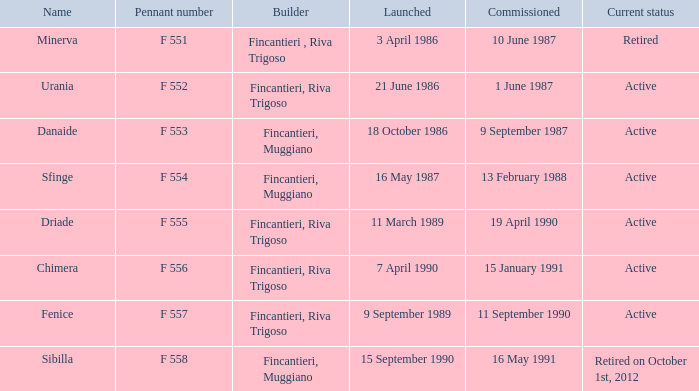What is the name of the developer who started in danaide? 18 October 1986. 